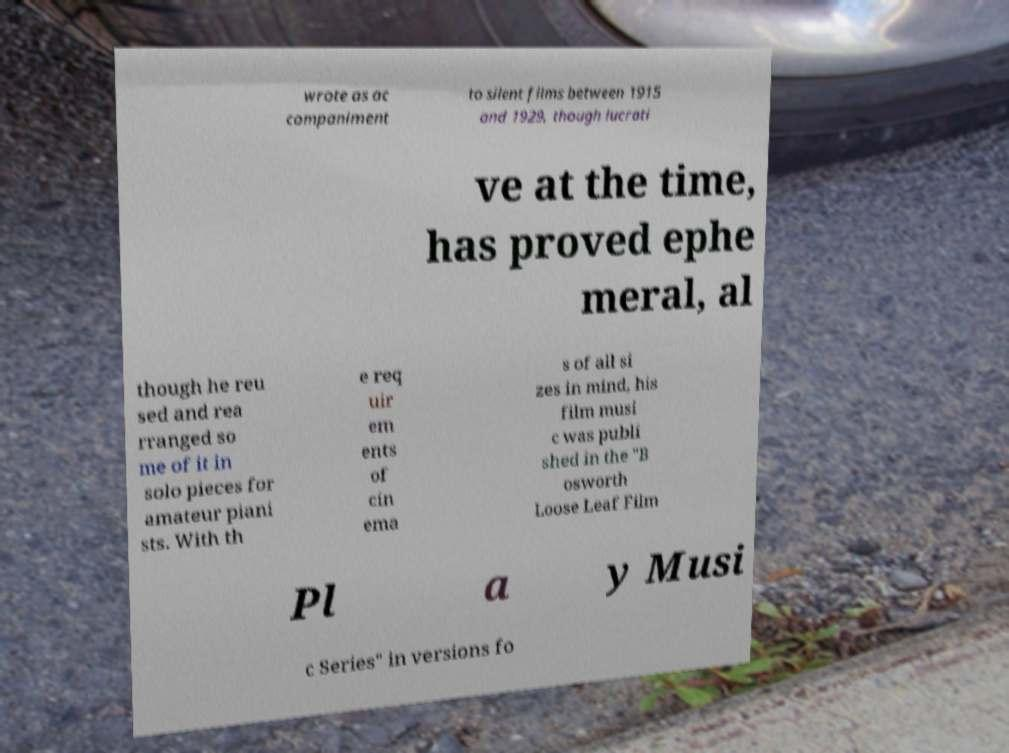Can you read and provide the text displayed in the image?This photo seems to have some interesting text. Can you extract and type it out for me? wrote as ac companiment to silent films between 1915 and 1929, though lucrati ve at the time, has proved ephe meral, al though he reu sed and rea rranged so me of it in solo pieces for amateur piani sts. With th e req uir em ents of cin ema s of all si zes in mind, his film musi c was publi shed in the "B osworth Loose Leaf Film Pl a y Musi c Series" in versions fo 